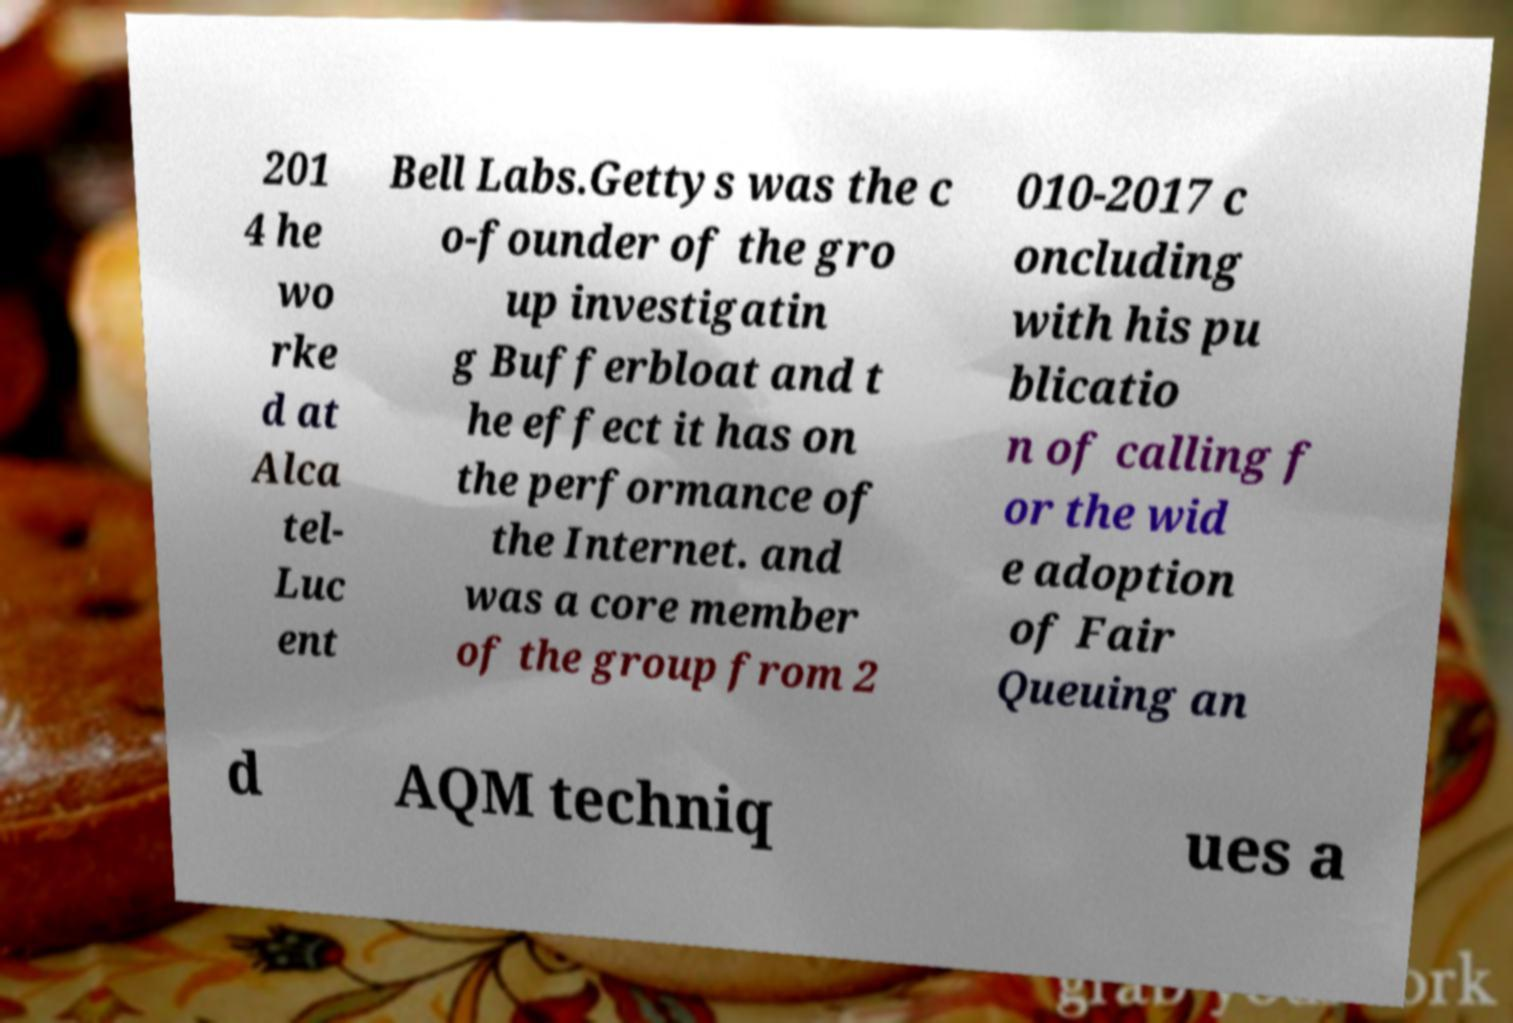Please identify and transcribe the text found in this image. 201 4 he wo rke d at Alca tel- Luc ent Bell Labs.Gettys was the c o-founder of the gro up investigatin g Bufferbloat and t he effect it has on the performance of the Internet. and was a core member of the group from 2 010-2017 c oncluding with his pu blicatio n of calling f or the wid e adoption of Fair Queuing an d AQM techniq ues a 